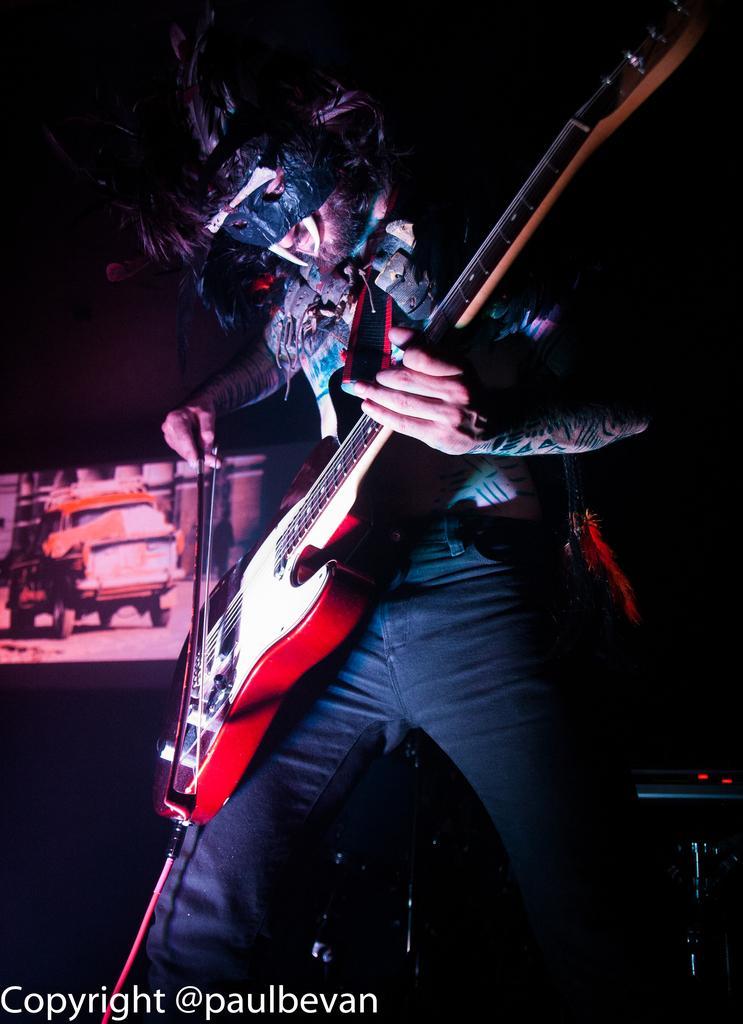Describe this image in one or two sentences. In this picture there is a person standing and holding guitar. In this background we can see screen. 